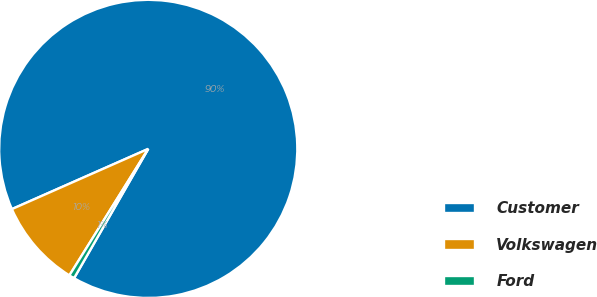<chart> <loc_0><loc_0><loc_500><loc_500><pie_chart><fcel>Customer<fcel>Volkswagen<fcel>Ford<nl><fcel>89.91%<fcel>9.51%<fcel>0.58%<nl></chart> 